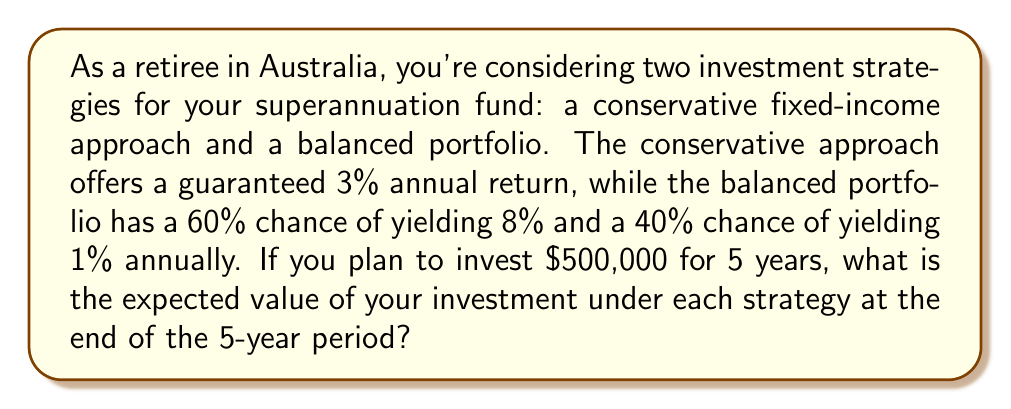Can you solve this math problem? Let's break this problem down step-by-step:

1. Conservative Fixed-Income Approach:
   This is a straightforward calculation using compound interest.
   
   $$FV = P(1+r)^n$$
   
   Where:
   $FV$ = Future Value
   $P$ = Principal (initial investment)
   $r$ = Annual interest rate
   $n$ = Number of years

   $$FV = 500,000 * (1 + 0.03)^5 = 500,000 * 1.159274 = $579,637$$

2. Balanced Portfolio Approach:
   For this, we need to calculate the expected annual return first.

   Expected Annual Return = (Probability of 8% * 8%) + (Probability of 1% * 1%)
   $$E(r) = (0.60 * 0.08) + (0.40 * 0.01) = 0.048 + 0.004 = 0.052 = 5.2\%$$

   Now we can use the same compound interest formula:

   $$FV = 500,000 * (1 + 0.052)^5 = 500,000 * 1.288416 = $644,208$$

3. Expected Value Comparison:
   Conservative approach: $579,637
   Balanced portfolio approach: $644,208

The expected value of the balanced portfolio is higher, but it comes with more risk. The conservative approach provides a guaranteed return, which might be preferable for some retirees who prioritize stability over potential higher returns.
Answer: Conservative Fixed-Income Approach: $579,637
Balanced Portfolio Approach: $644,208 